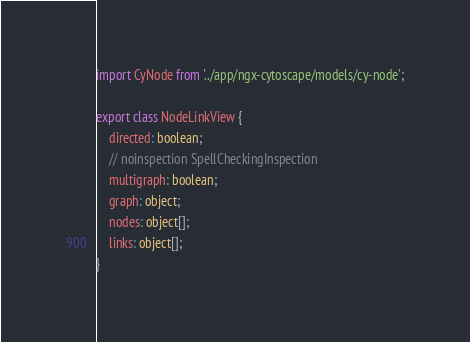Convert code to text. <code><loc_0><loc_0><loc_500><loc_500><_TypeScript_>import CyNode from '../app/ngx-cytoscape/models/cy-node';

export class NodeLinkView {
    directed: boolean;
    // noinspection SpellCheckingInspection
    multigraph: boolean;
    graph: object;
    nodes: object[];
    links: object[];
}


</code> 